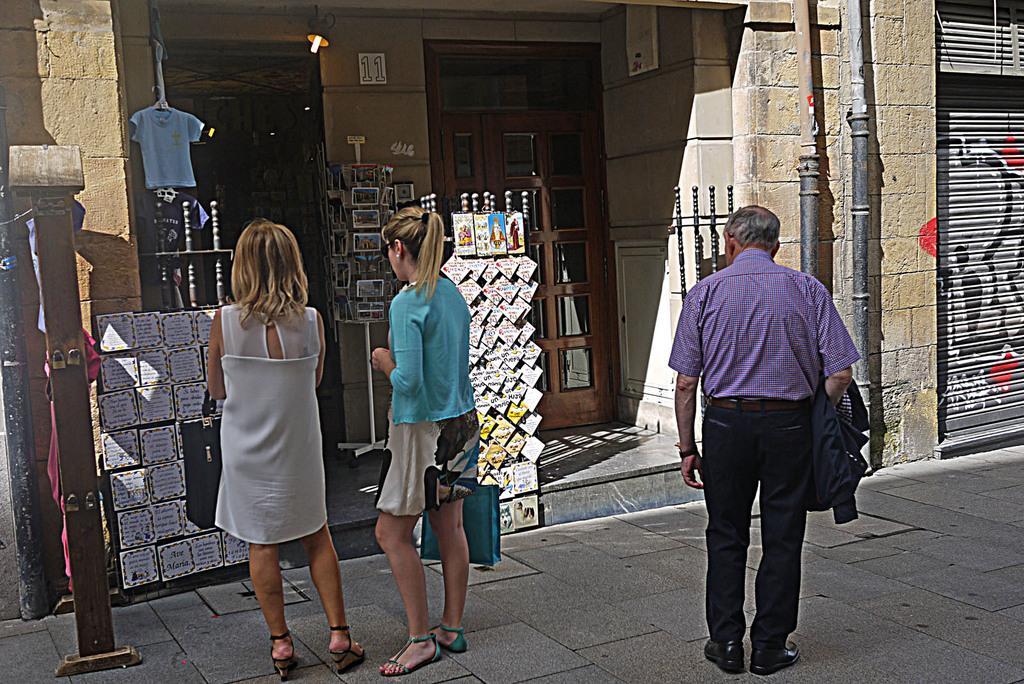Can you describe this image briefly? In this image I can see three people standing in-front of the shop. These people are wearing the different color dresses and one person is holding the bag. In-front of these people there are stickers attached to the board. In the back I can see the t-shirt hanged and the light. To the right there is a shutter and the pipes to the wall. 